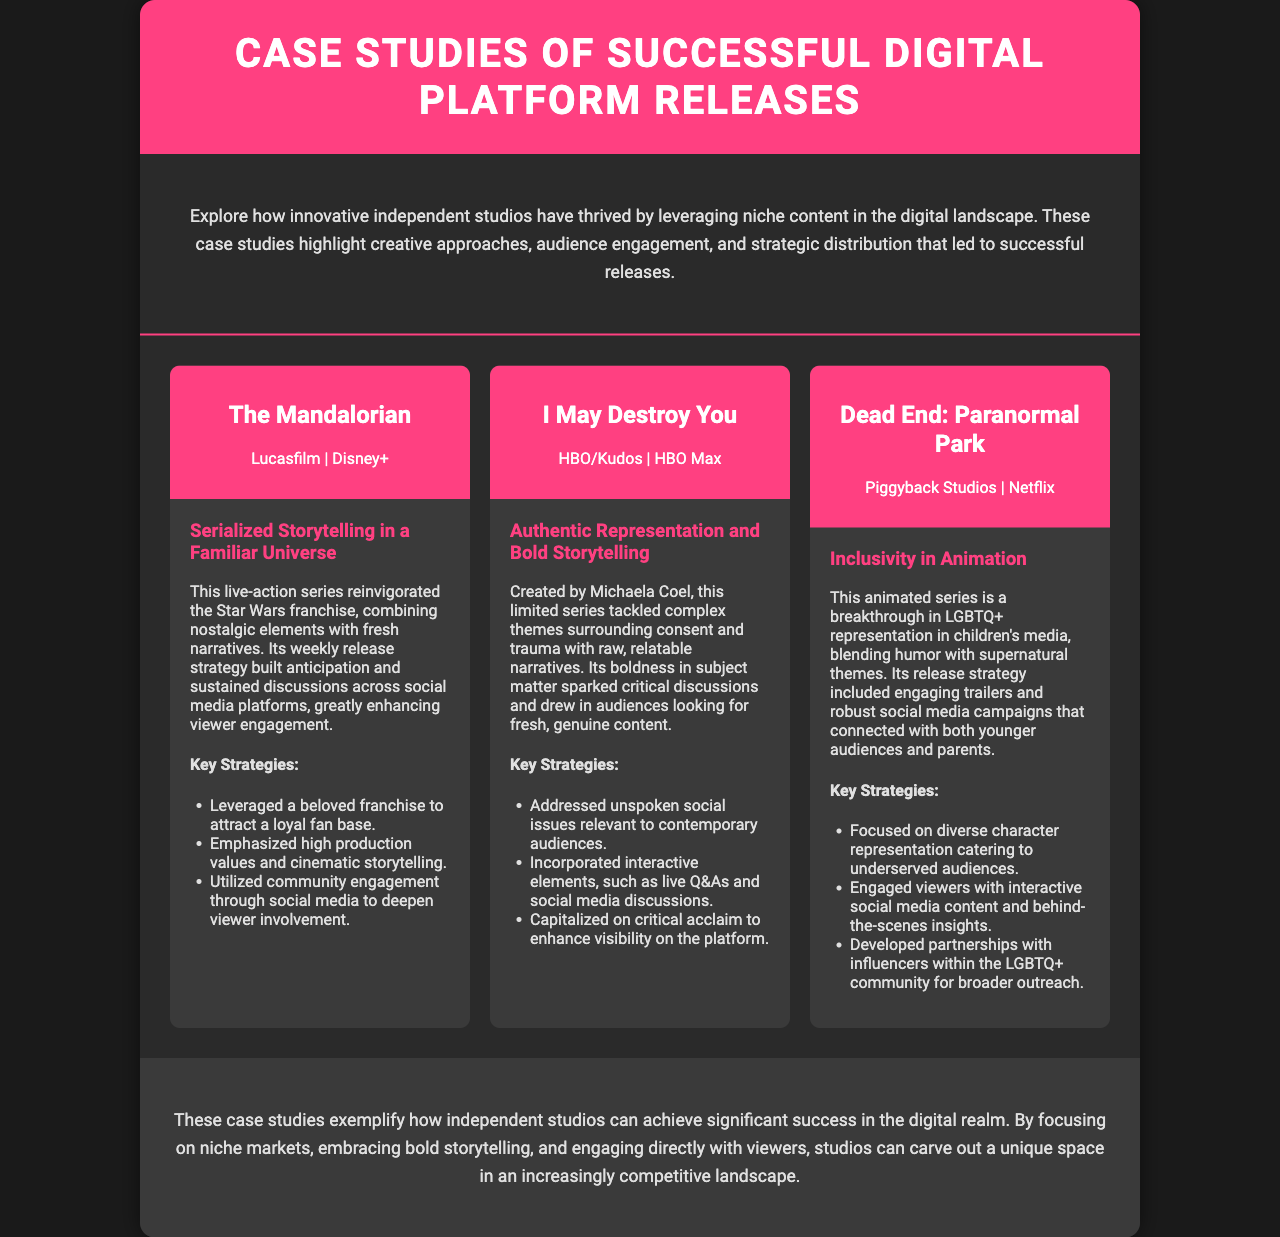What is the title of the brochure? The title is presented in the header section of the document.
Answer: Case Studies of Successful Digital Platform Releases Which series is created by Michaela Coel? This information is found within the case study details.
Answer: I May Destroy You What platform released "The Mandalorian"? The platform is mentioned in the case study header.
Answer: Disney+ What theme does "I May Destroy You" address? This theme is discussed in the description of the case study.
Answer: Consent and trauma Which animated series focuses on LGBTQ+ representation? This detail can be found in the case study overview for that specific series.
Answer: Dead End: Paranormal Park What was a key strategy of "The Mandalorian"? The key strategies are listed in bullet points under its case study.
Answer: Leveraged a beloved franchise to attract a loyal fan base What is the common goal of the case studies presented? This goal is summarized in the conclusion section of the document.
Answer: Achieve significant success in the digital realm How many case studies are highlighted in the brochure? The number can be counted by reviewing the case studies section of the document.
Answer: Three 